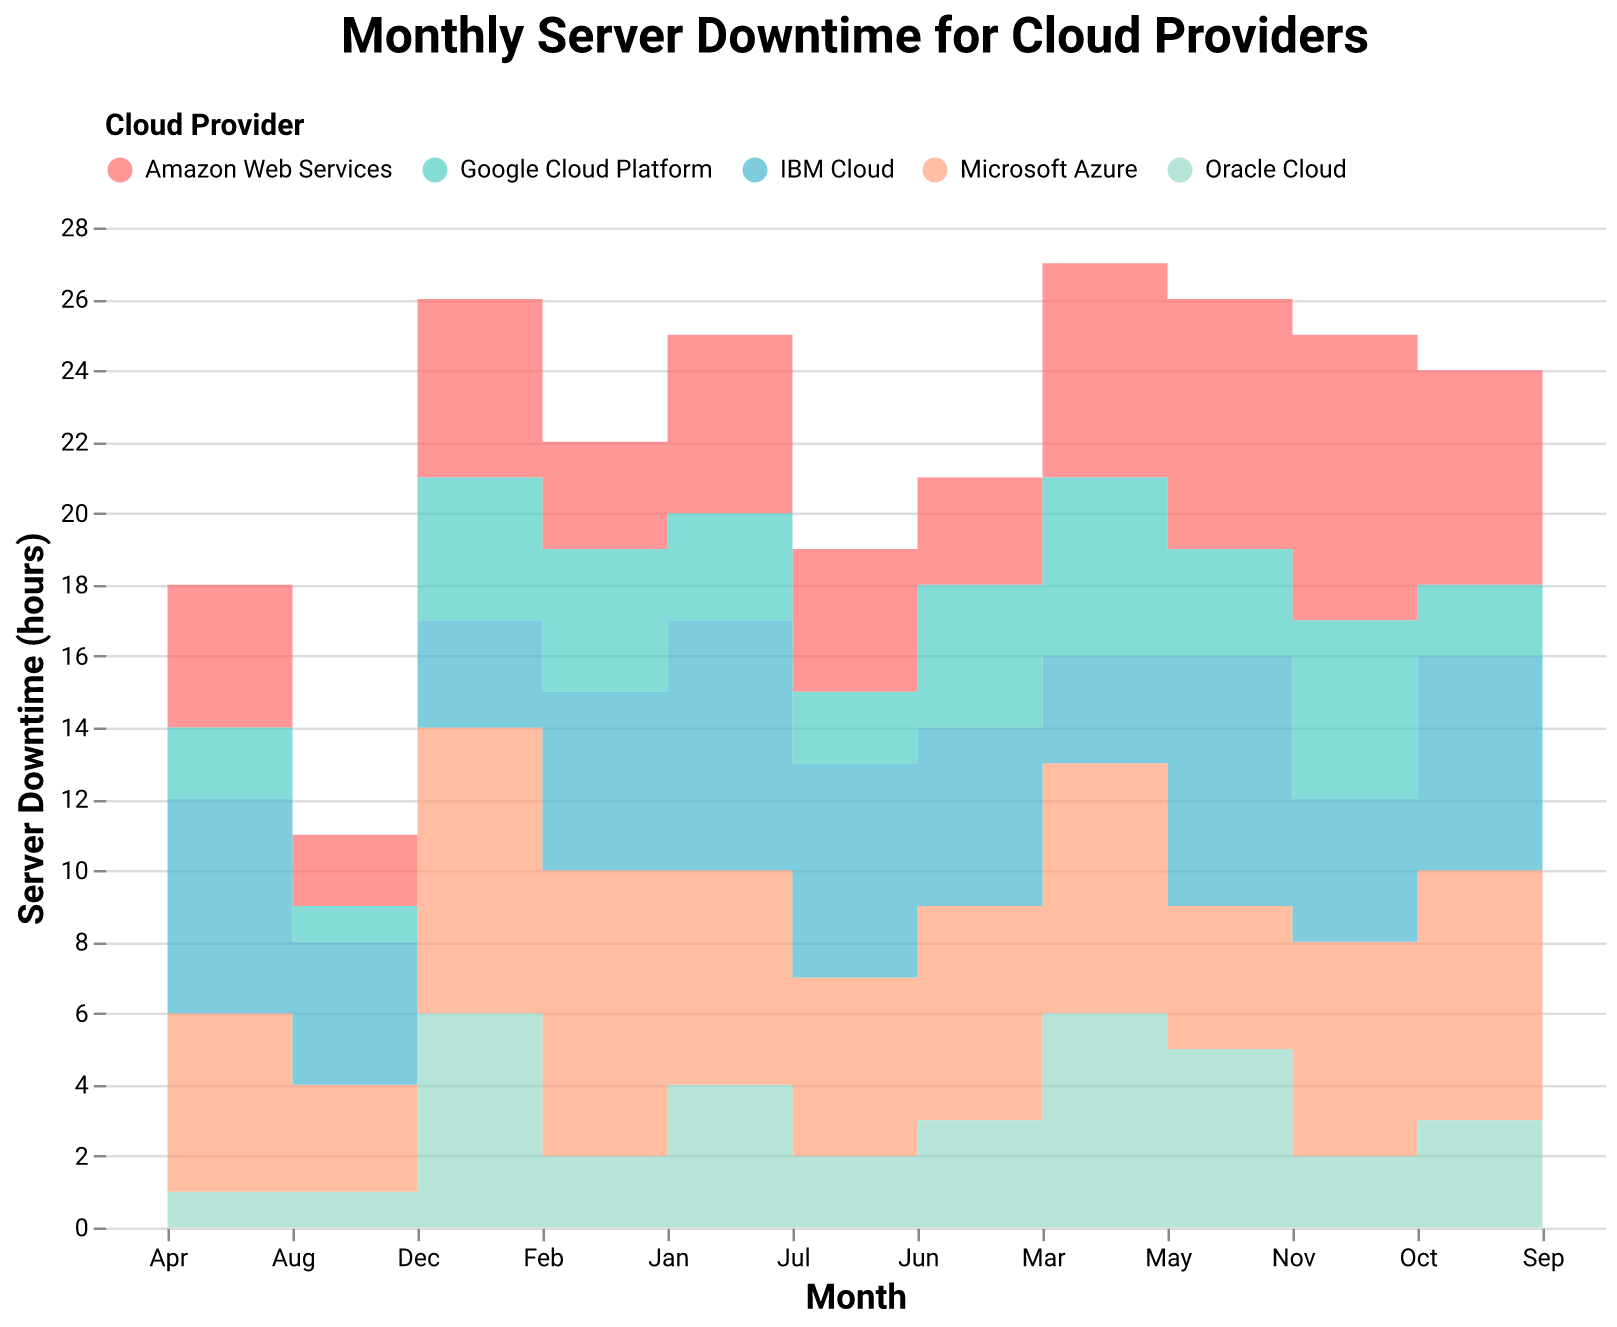What is the title of the figure? The title can be found at the top of the figure.
Answer: Monthly Server Downtime for Cloud Providers Which cloud provider had the highest server downtime in January? Look at the step area corresponding to January and identify the provider with the highest value.
Answer: IBM Cloud How many hours of server downtime did Microsoft Azure have in March? Check the March value specifically for the Microsoft Azure series.
Answer: 7 hours Which month had the lowest downtime for Oracle Cloud? Locate the lowest point for Oracle Cloud on the chart and identify the corresponding month.
Answer: August What was the total server downtime for Google Cloud Platform in the first quarter of the year (Jan, Feb, Mar)? Sum the downtime values for Google Cloud Platform for January, February, and March.
Answer: 3 + 4 + 5 = 12 hours Which cloud provider experienced an increase in server downtime from February to March? Compare the February and March values for each provider to see which experienced an increase.
Answer: Amazon Web Services (increase from 3 to 6) What's the average monthly server downtime for Amazon Web Services over the entire year? Sum the monthly downtime values for Amazon Web Services and divide by the total number of months (12).
Answer: (5 + 3 + 6 + 4 + 7 + 3 + 4 + 2 + 3 + 6 + 8 + 5) / 12 = 4.58 hours Between June and August, which cloud provider had the most consistent downtime (least variation)? Compare the downtime values for each provider between June and August to identify the one with the least variation.
Answer: Oracle Cloud (3, 2, 1) Which month had the most significant difference in downtime between the cloud provider with the highest and the one with the lowest downtime? Find the month with the largest gap between the highest and lowest downtime values.
Answer: November (8 - 2 = 6 hours) How does the server downtime trend for IBM Cloud from August to December look? Observe the IBM Cloud series from August to December to identify the trend.
Answer: Decreasing trend 